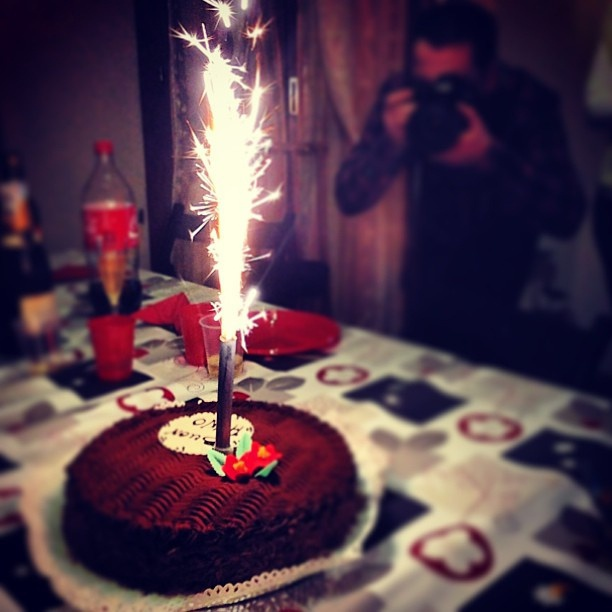Describe the objects in this image and their specific colors. I can see dining table in black, maroon, and gray tones, people in black, navy, and purple tones, cake in black, maroon, khaki, and brown tones, bottle in black, purple, navy, and brown tones, and bottle in black, brown, and maroon tones in this image. 